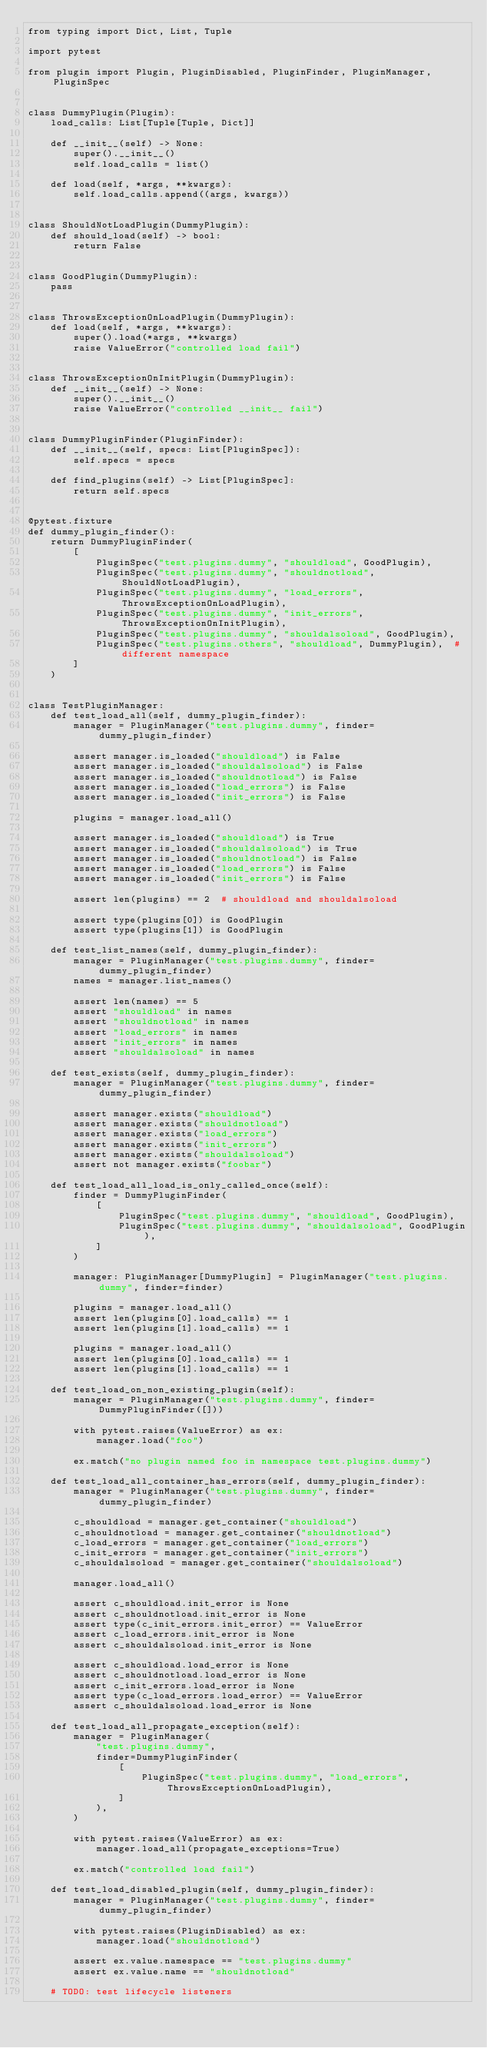Convert code to text. <code><loc_0><loc_0><loc_500><loc_500><_Python_>from typing import Dict, List, Tuple

import pytest

from plugin import Plugin, PluginDisabled, PluginFinder, PluginManager, PluginSpec


class DummyPlugin(Plugin):
    load_calls: List[Tuple[Tuple, Dict]]

    def __init__(self) -> None:
        super().__init__()
        self.load_calls = list()

    def load(self, *args, **kwargs):
        self.load_calls.append((args, kwargs))


class ShouldNotLoadPlugin(DummyPlugin):
    def should_load(self) -> bool:
        return False


class GoodPlugin(DummyPlugin):
    pass


class ThrowsExceptionOnLoadPlugin(DummyPlugin):
    def load(self, *args, **kwargs):
        super().load(*args, **kwargs)
        raise ValueError("controlled load fail")


class ThrowsExceptionOnInitPlugin(DummyPlugin):
    def __init__(self) -> None:
        super().__init__()
        raise ValueError("controlled __init__ fail")


class DummyPluginFinder(PluginFinder):
    def __init__(self, specs: List[PluginSpec]):
        self.specs = specs

    def find_plugins(self) -> List[PluginSpec]:
        return self.specs


@pytest.fixture
def dummy_plugin_finder():
    return DummyPluginFinder(
        [
            PluginSpec("test.plugins.dummy", "shouldload", GoodPlugin),
            PluginSpec("test.plugins.dummy", "shouldnotload", ShouldNotLoadPlugin),
            PluginSpec("test.plugins.dummy", "load_errors", ThrowsExceptionOnLoadPlugin),
            PluginSpec("test.plugins.dummy", "init_errors", ThrowsExceptionOnInitPlugin),
            PluginSpec("test.plugins.dummy", "shouldalsoload", GoodPlugin),
            PluginSpec("test.plugins.others", "shouldload", DummyPlugin),  # different namespace
        ]
    )


class TestPluginManager:
    def test_load_all(self, dummy_plugin_finder):
        manager = PluginManager("test.plugins.dummy", finder=dummy_plugin_finder)

        assert manager.is_loaded("shouldload") is False
        assert manager.is_loaded("shouldalsoload") is False
        assert manager.is_loaded("shouldnotload") is False
        assert manager.is_loaded("load_errors") is False
        assert manager.is_loaded("init_errors") is False

        plugins = manager.load_all()

        assert manager.is_loaded("shouldload") is True
        assert manager.is_loaded("shouldalsoload") is True
        assert manager.is_loaded("shouldnotload") is False
        assert manager.is_loaded("load_errors") is False
        assert manager.is_loaded("init_errors") is False

        assert len(plugins) == 2  # shouldload and shouldalsoload

        assert type(plugins[0]) is GoodPlugin
        assert type(plugins[1]) is GoodPlugin

    def test_list_names(self, dummy_plugin_finder):
        manager = PluginManager("test.plugins.dummy", finder=dummy_plugin_finder)
        names = manager.list_names()

        assert len(names) == 5
        assert "shouldload" in names
        assert "shouldnotload" in names
        assert "load_errors" in names
        assert "init_errors" in names
        assert "shouldalsoload" in names

    def test_exists(self, dummy_plugin_finder):
        manager = PluginManager("test.plugins.dummy", finder=dummy_plugin_finder)

        assert manager.exists("shouldload")
        assert manager.exists("shouldnotload")
        assert manager.exists("load_errors")
        assert manager.exists("init_errors")
        assert manager.exists("shouldalsoload")
        assert not manager.exists("foobar")

    def test_load_all_load_is_only_called_once(self):
        finder = DummyPluginFinder(
            [
                PluginSpec("test.plugins.dummy", "shouldload", GoodPlugin),
                PluginSpec("test.plugins.dummy", "shouldalsoload", GoodPlugin),
            ]
        )

        manager: PluginManager[DummyPlugin] = PluginManager("test.plugins.dummy", finder=finder)

        plugins = manager.load_all()
        assert len(plugins[0].load_calls) == 1
        assert len(plugins[1].load_calls) == 1

        plugins = manager.load_all()
        assert len(plugins[0].load_calls) == 1
        assert len(plugins[1].load_calls) == 1

    def test_load_on_non_existing_plugin(self):
        manager = PluginManager("test.plugins.dummy", finder=DummyPluginFinder([]))

        with pytest.raises(ValueError) as ex:
            manager.load("foo")

        ex.match("no plugin named foo in namespace test.plugins.dummy")

    def test_load_all_container_has_errors(self, dummy_plugin_finder):
        manager = PluginManager("test.plugins.dummy", finder=dummy_plugin_finder)

        c_shouldload = manager.get_container("shouldload")
        c_shouldnotload = manager.get_container("shouldnotload")
        c_load_errors = manager.get_container("load_errors")
        c_init_errors = manager.get_container("init_errors")
        c_shouldalsoload = manager.get_container("shouldalsoload")

        manager.load_all()

        assert c_shouldload.init_error is None
        assert c_shouldnotload.init_error is None
        assert type(c_init_errors.init_error) == ValueError
        assert c_load_errors.init_error is None
        assert c_shouldalsoload.init_error is None

        assert c_shouldload.load_error is None
        assert c_shouldnotload.load_error is None
        assert c_init_errors.load_error is None
        assert type(c_load_errors.load_error) == ValueError
        assert c_shouldalsoload.load_error is None

    def test_load_all_propagate_exception(self):
        manager = PluginManager(
            "test.plugins.dummy",
            finder=DummyPluginFinder(
                [
                    PluginSpec("test.plugins.dummy", "load_errors", ThrowsExceptionOnLoadPlugin),
                ]
            ),
        )

        with pytest.raises(ValueError) as ex:
            manager.load_all(propagate_exceptions=True)

        ex.match("controlled load fail")

    def test_load_disabled_plugin(self, dummy_plugin_finder):
        manager = PluginManager("test.plugins.dummy", finder=dummy_plugin_finder)

        with pytest.raises(PluginDisabled) as ex:
            manager.load("shouldnotload")

        assert ex.value.namespace == "test.plugins.dummy"
        assert ex.value.name == "shouldnotload"

    # TODO: test lifecycle listeners
</code> 